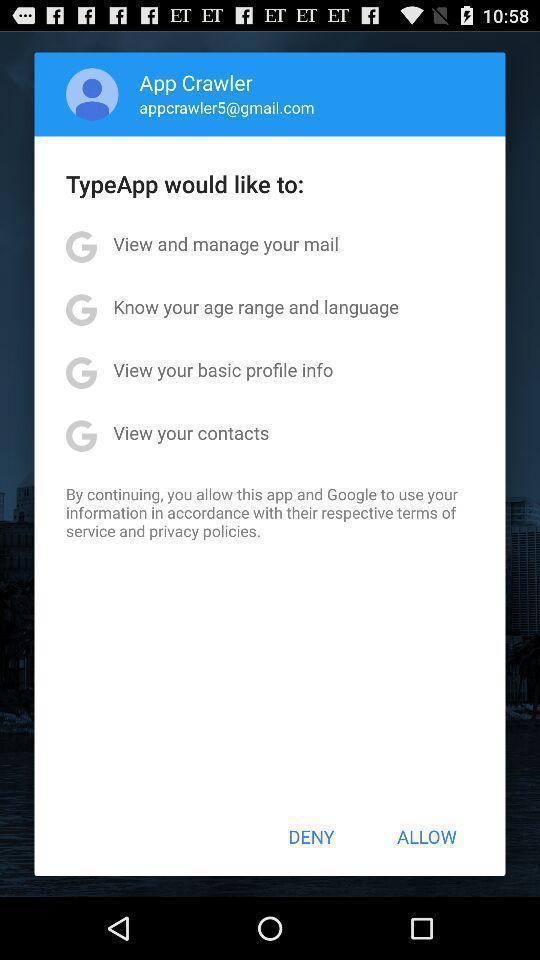Describe the key features of this screenshot. Push up displaying for social app. 